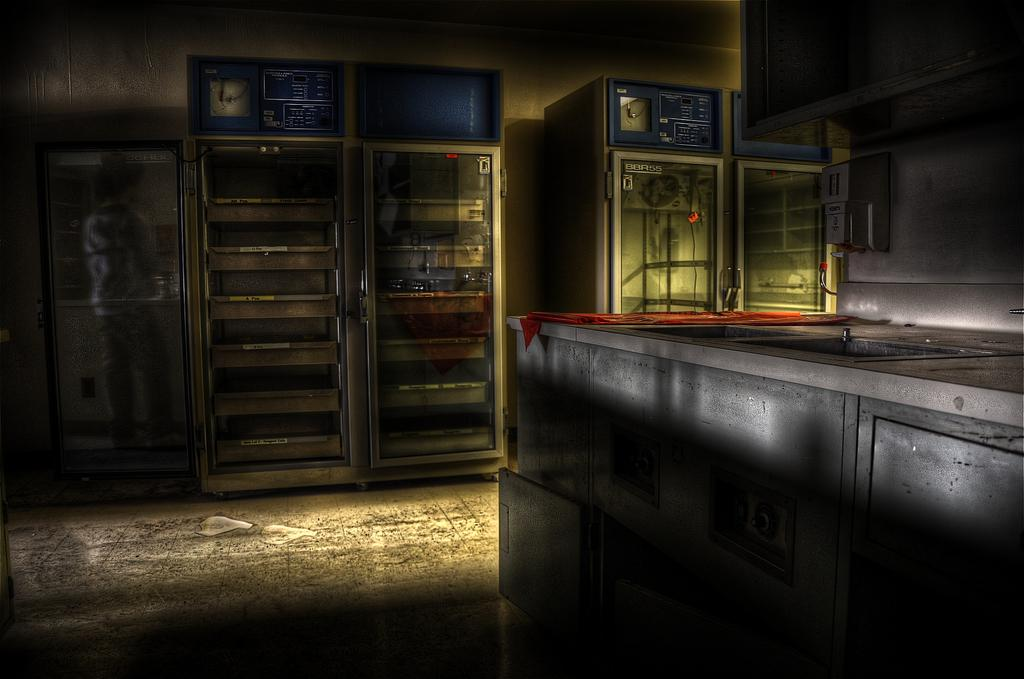What is the main piece of furniture in the room? There is a big table in the room. What can be found beside the table? There are four empty refrigerators beside the table. Where is the door located in the room? The door is on the left side of the room. Can you describe what is behind the door? There is a person behind the door. What type of test is being conducted in the room? There is no indication of a test being conducted in the room; the facts provided do not mention any testing or competition. 